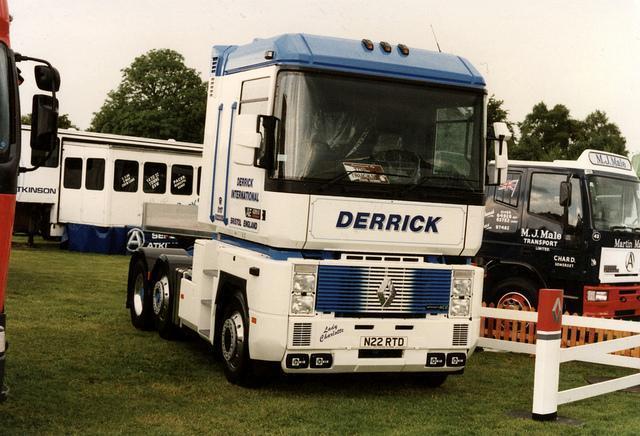How many trucks are there?
Give a very brief answer. 4. 